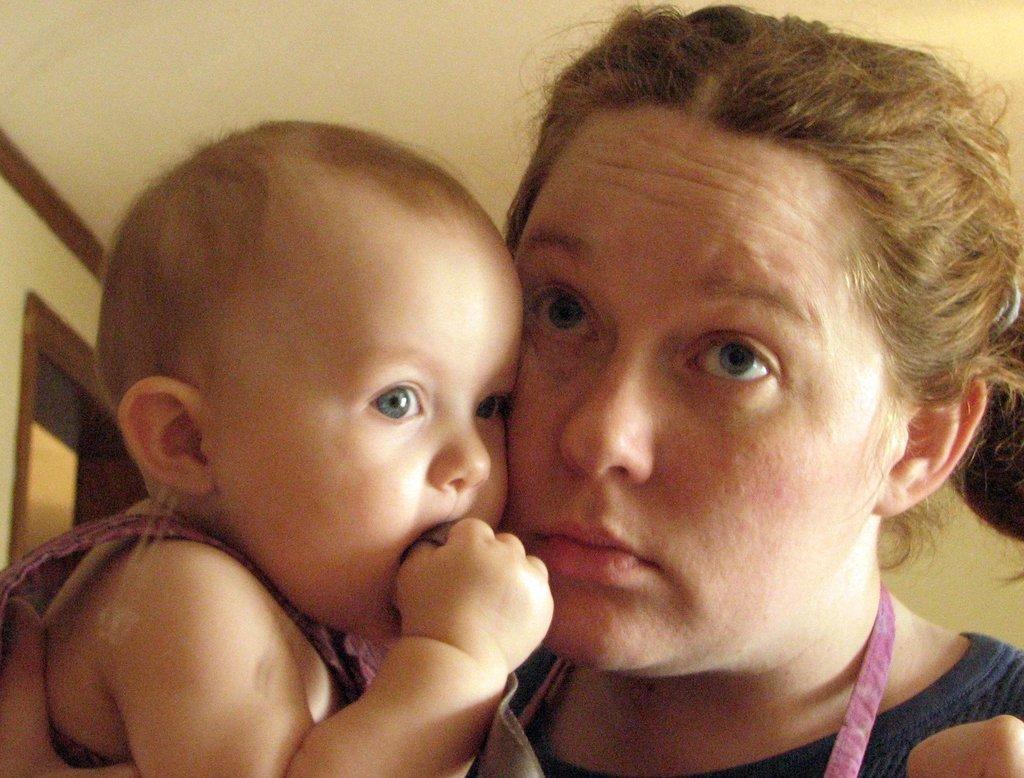How would you summarize this image in a sentence or two? In this image we can see a woman holding a baby in her hand. In the background we can see a door. 